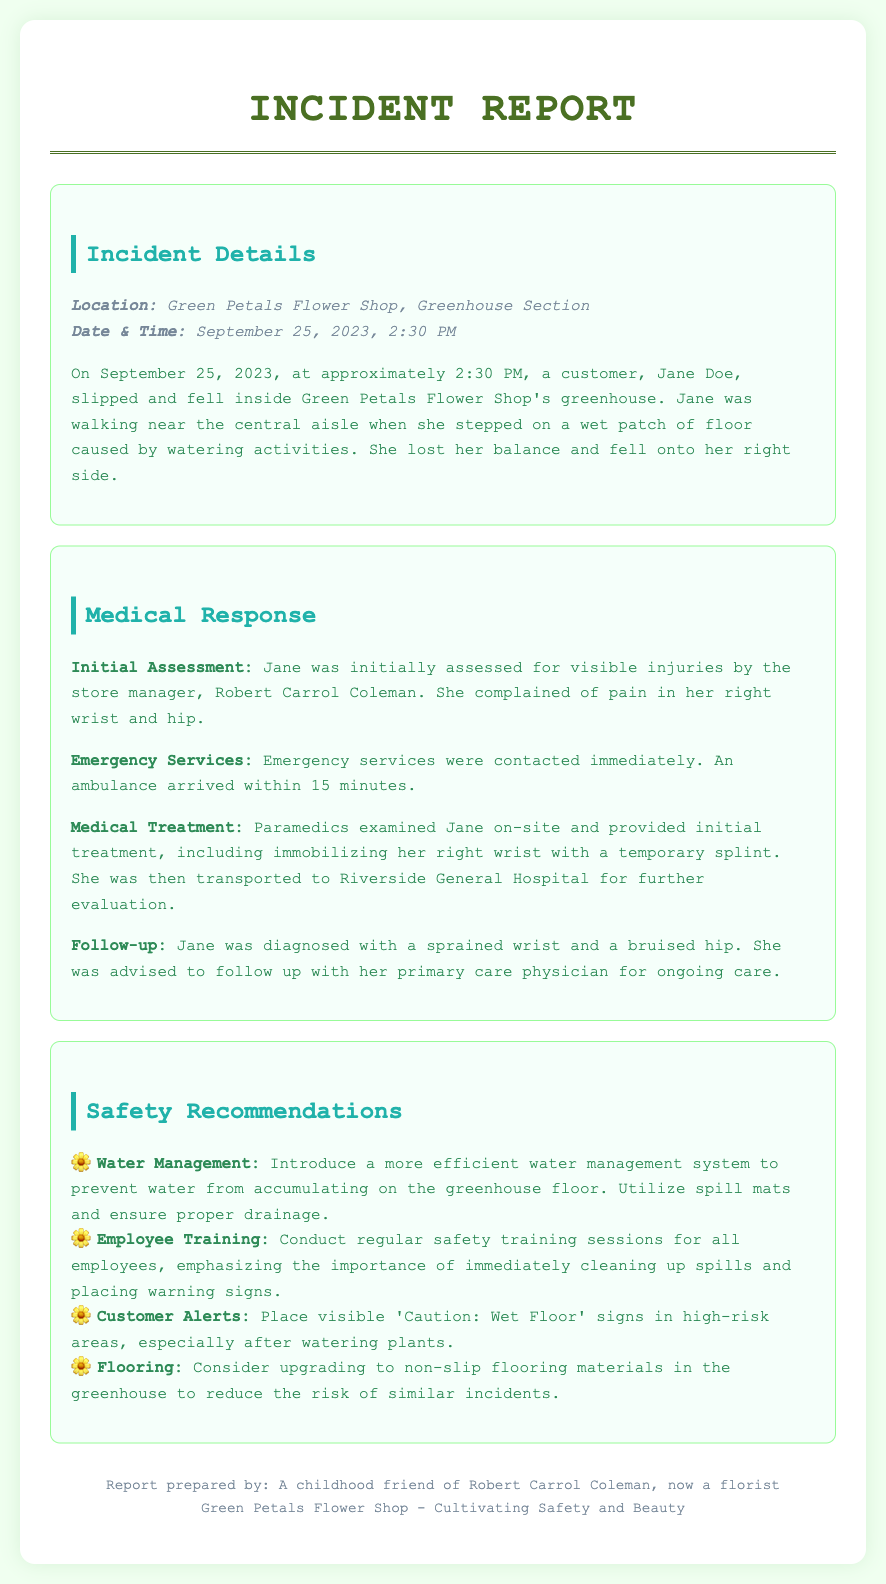What is the date and time of the accident? The date and time of the accident are specified in the document, indicating when the incident occurred.
Answer: September 25, 2023, 2:30 PM Who was the customer involved in the incident? The document names the customer who slipped and fell, providing specific identifying details about her.
Answer: Jane Doe What injury did Jane complain of after the fall? The report highlights the specific complaints Jane made about her injuries following the incident, reflecting her condition.
Answer: Pain in her right wrist and hip How long did it take for the ambulance to arrive? The response provides a specific time frame for how quickly emergency services responded to the situation.
Answer: 15 minutes What is one recommendation for improving water management? The safety recommendations section includes specific suggestions for preventing future incidents related to water accumulation.
Answer: Introduce a more efficient water management system Why is it important to place warning signs according to the report? The document emphasizes the necessity of warning signs, indicating their purpose in maintaining safety in the greenhouse environment.
Answer: To alert customers to wet areas What type of flooring is recommended in the report? The recommendations include a suggestion for the type of flooring that could reduce incidents in the greenhouse.
Answer: Non-slip flooring materials Who prepared the report? The footer contains information about who compiled the document, which gives context regarding the authorship.
Answer: A childhood friend of Robert Carrol Coleman, now a florist 